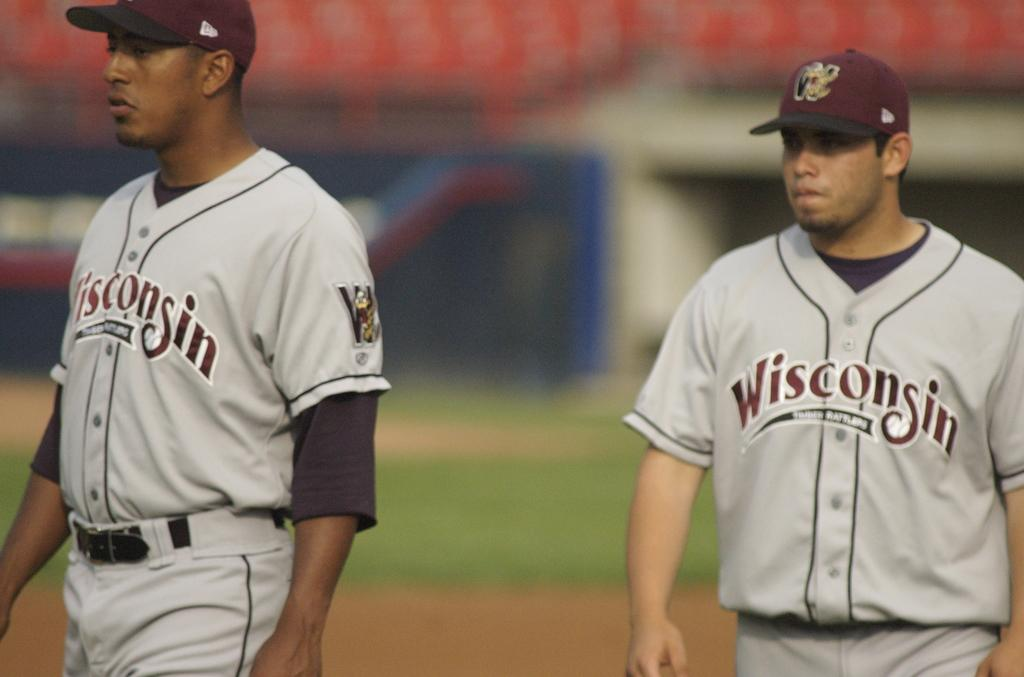How many players are visible in the image? There are two players in the image. Where are the players located? The players are in a stadium. What is the condition of the stadium stands in the image? The stadium stands are empty. What type of surface is at the bottom of the image? There is grass on the surface at the bottom of the image. What type of rabbit can be seen jumping over the players in the image? There is no rabbit present in the image, and therefore no such activity can be observed. 